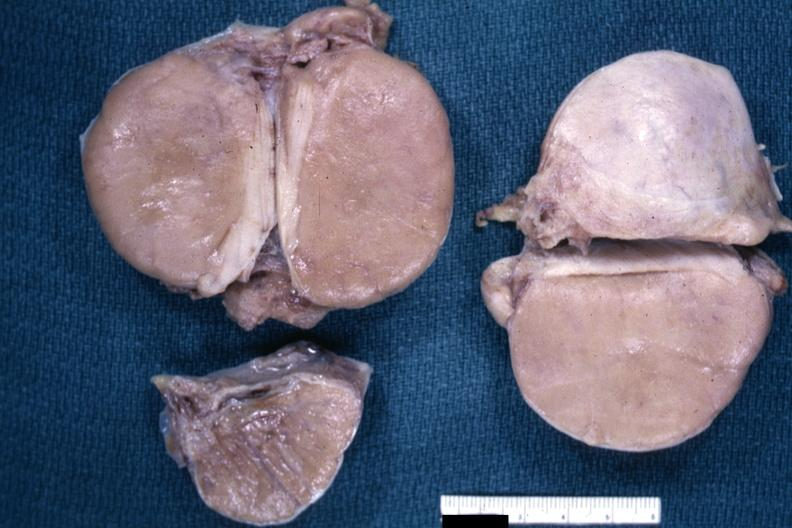s malignant lymphoma present?
Answer the question using a single word or phrase. Yes 